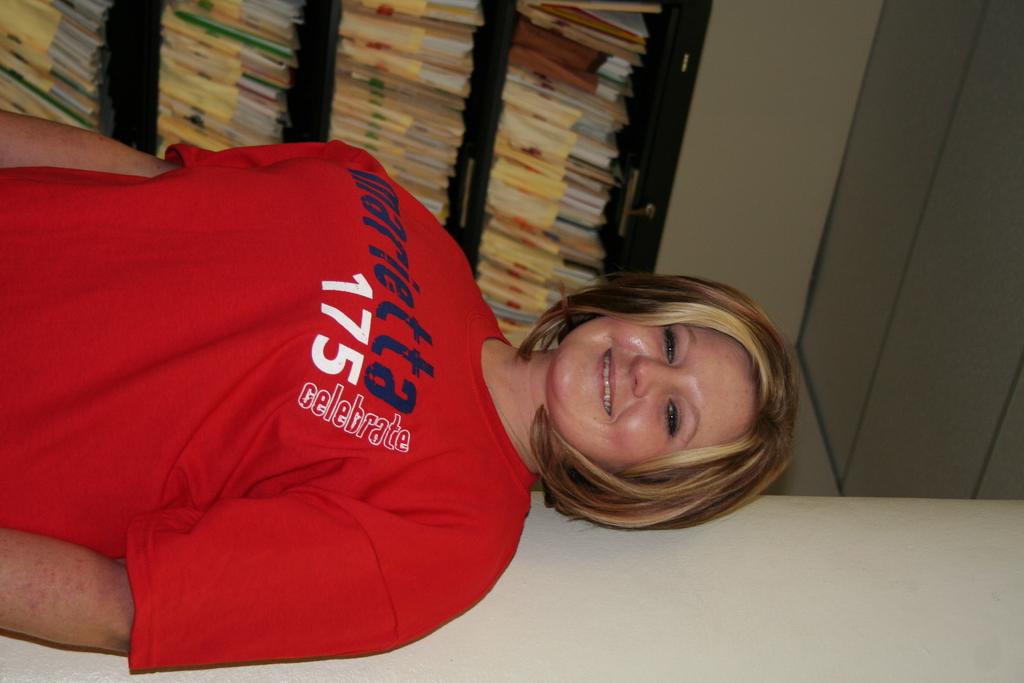What number was written on the shirt?
Make the answer very short. 175. Does it say to celebrate?
Offer a terse response. Yes. 